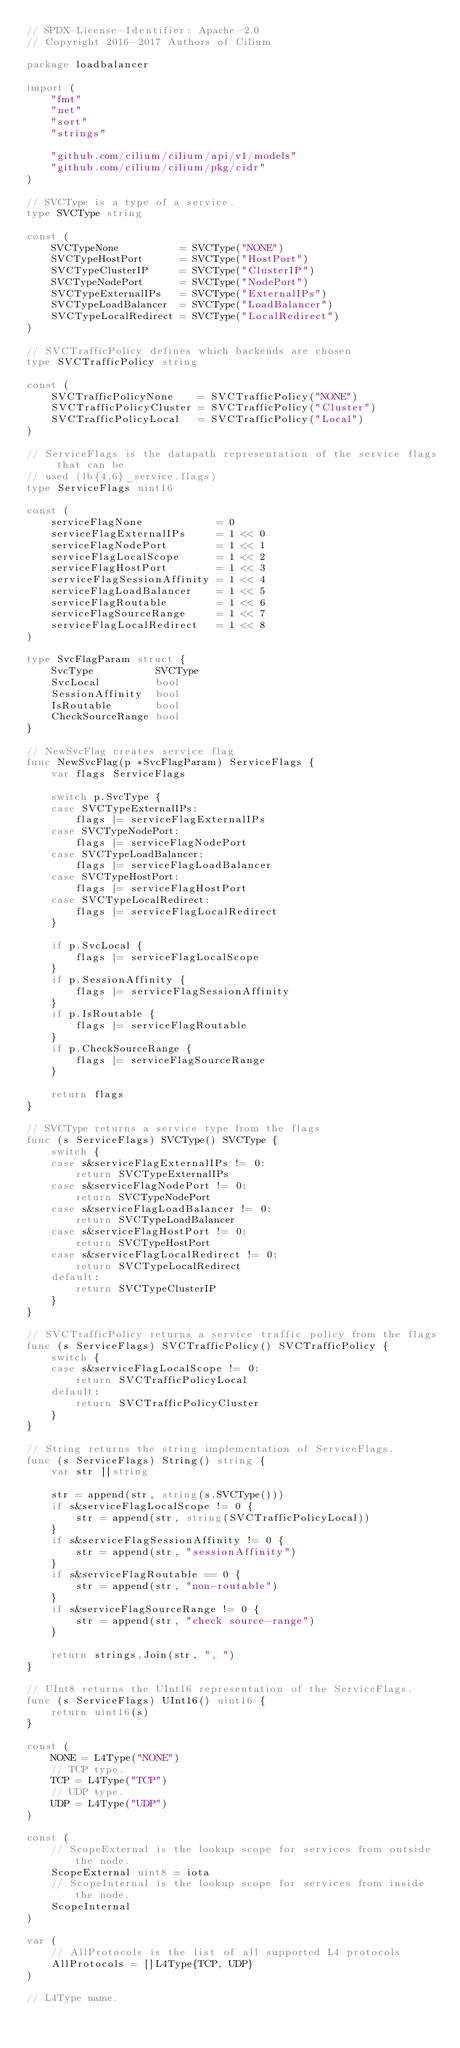<code> <loc_0><loc_0><loc_500><loc_500><_Go_>// SPDX-License-Identifier: Apache-2.0
// Copyright 2016-2017 Authors of Cilium

package loadbalancer

import (
	"fmt"
	"net"
	"sort"
	"strings"

	"github.com/cilium/cilium/api/v1/models"
	"github.com/cilium/cilium/pkg/cidr"
)

// SVCType is a type of a service.
type SVCType string

const (
	SVCTypeNone          = SVCType("NONE")
	SVCTypeHostPort      = SVCType("HostPort")
	SVCTypeClusterIP     = SVCType("ClusterIP")
	SVCTypeNodePort      = SVCType("NodePort")
	SVCTypeExternalIPs   = SVCType("ExternalIPs")
	SVCTypeLoadBalancer  = SVCType("LoadBalancer")
	SVCTypeLocalRedirect = SVCType("LocalRedirect")
)

// SVCTrafficPolicy defines which backends are chosen
type SVCTrafficPolicy string

const (
	SVCTrafficPolicyNone    = SVCTrafficPolicy("NONE")
	SVCTrafficPolicyCluster = SVCTrafficPolicy("Cluster")
	SVCTrafficPolicyLocal   = SVCTrafficPolicy("Local")
)

// ServiceFlags is the datapath representation of the service flags that can be
// used (lb{4,6}_service.flags)
type ServiceFlags uint16

const (
	serviceFlagNone            = 0
	serviceFlagExternalIPs     = 1 << 0
	serviceFlagNodePort        = 1 << 1
	serviceFlagLocalScope      = 1 << 2
	serviceFlagHostPort        = 1 << 3
	serviceFlagSessionAffinity = 1 << 4
	serviceFlagLoadBalancer    = 1 << 5
	serviceFlagRoutable        = 1 << 6
	serviceFlagSourceRange     = 1 << 7
	serviceFlagLocalRedirect   = 1 << 8
)

type SvcFlagParam struct {
	SvcType          SVCType
	SvcLocal         bool
	SessionAffinity  bool
	IsRoutable       bool
	CheckSourceRange bool
}

// NewSvcFlag creates service flag
func NewSvcFlag(p *SvcFlagParam) ServiceFlags {
	var flags ServiceFlags

	switch p.SvcType {
	case SVCTypeExternalIPs:
		flags |= serviceFlagExternalIPs
	case SVCTypeNodePort:
		flags |= serviceFlagNodePort
	case SVCTypeLoadBalancer:
		flags |= serviceFlagLoadBalancer
	case SVCTypeHostPort:
		flags |= serviceFlagHostPort
	case SVCTypeLocalRedirect:
		flags |= serviceFlagLocalRedirect
	}

	if p.SvcLocal {
		flags |= serviceFlagLocalScope
	}
	if p.SessionAffinity {
		flags |= serviceFlagSessionAffinity
	}
	if p.IsRoutable {
		flags |= serviceFlagRoutable
	}
	if p.CheckSourceRange {
		flags |= serviceFlagSourceRange
	}

	return flags
}

// SVCType returns a service type from the flags
func (s ServiceFlags) SVCType() SVCType {
	switch {
	case s&serviceFlagExternalIPs != 0:
		return SVCTypeExternalIPs
	case s&serviceFlagNodePort != 0:
		return SVCTypeNodePort
	case s&serviceFlagLoadBalancer != 0:
		return SVCTypeLoadBalancer
	case s&serviceFlagHostPort != 0:
		return SVCTypeHostPort
	case s&serviceFlagLocalRedirect != 0:
		return SVCTypeLocalRedirect
	default:
		return SVCTypeClusterIP
	}
}

// SVCTrafficPolicy returns a service traffic policy from the flags
func (s ServiceFlags) SVCTrafficPolicy() SVCTrafficPolicy {
	switch {
	case s&serviceFlagLocalScope != 0:
		return SVCTrafficPolicyLocal
	default:
		return SVCTrafficPolicyCluster
	}
}

// String returns the string implementation of ServiceFlags.
func (s ServiceFlags) String() string {
	var str []string

	str = append(str, string(s.SVCType()))
	if s&serviceFlagLocalScope != 0 {
		str = append(str, string(SVCTrafficPolicyLocal))
	}
	if s&serviceFlagSessionAffinity != 0 {
		str = append(str, "sessionAffinity")
	}
	if s&serviceFlagRoutable == 0 {
		str = append(str, "non-routable")
	}
	if s&serviceFlagSourceRange != 0 {
		str = append(str, "check source-range")
	}

	return strings.Join(str, ", ")
}

// UInt8 returns the UInt16 representation of the ServiceFlags.
func (s ServiceFlags) UInt16() uint16 {
	return uint16(s)
}

const (
	NONE = L4Type("NONE")
	// TCP type.
	TCP = L4Type("TCP")
	// UDP type.
	UDP = L4Type("UDP")
)

const (
	// ScopeExternal is the lookup scope for services from outside the node.
	ScopeExternal uint8 = iota
	// ScopeInternal is the lookup scope for services from inside the node.
	ScopeInternal
)

var (
	// AllProtocols is the list of all supported L4 protocols
	AllProtocols = []L4Type{TCP, UDP}
)

// L4Type name.</code> 